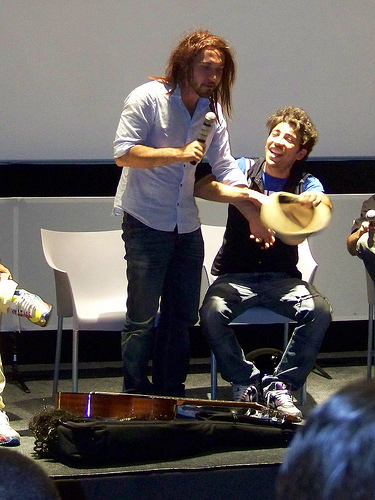<image>
Is there a guitar on the case? Yes. Looking at the image, I can see the guitar is positioned on top of the case, with the case providing support. 